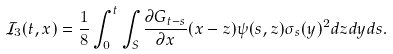Convert formula to latex. <formula><loc_0><loc_0><loc_500><loc_500>\mathcal { I } _ { 3 } ( t , x ) = \frac { 1 } { 8 } \int _ { 0 } ^ { t } \int _ { S } \frac { \partial G _ { t - s } } { \partial x } ( x - z ) \psi ( s , z ) \sigma _ { s } ( y ) ^ { 2 } d z d y d s .</formula> 